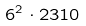<formula> <loc_0><loc_0><loc_500><loc_500>6 ^ { 2 } \cdot 2 3 1 0</formula> 